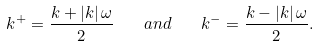Convert formula to latex. <formula><loc_0><loc_0><loc_500><loc_500>k ^ { + } = \frac { k + \left | k \right | \omega } { 2 } \quad a n d \quad k ^ { - } = \frac { k - \left | k \right | \omega } { 2 } .</formula> 